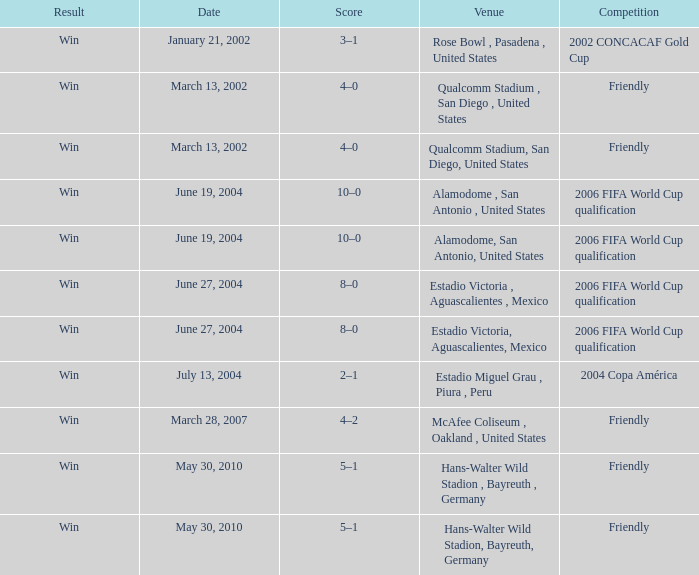Would you mind parsing the complete table? {'header': ['Result', 'Date', 'Score', 'Venue', 'Competition'], 'rows': [['Win', 'January 21, 2002', '3–1', 'Rose Bowl , Pasadena , United States', '2002 CONCACAF Gold Cup'], ['Win', 'March 13, 2002', '4–0', 'Qualcomm Stadium , San Diego , United States', 'Friendly'], ['Win', 'March 13, 2002', '4–0', 'Qualcomm Stadium, San Diego, United States', 'Friendly'], ['Win', 'June 19, 2004', '10–0', 'Alamodome , San Antonio , United States', '2006 FIFA World Cup qualification'], ['Win', 'June 19, 2004', '10–0', 'Alamodome, San Antonio, United States', '2006 FIFA World Cup qualification'], ['Win', 'June 27, 2004', '8–0', 'Estadio Victoria , Aguascalientes , Mexico', '2006 FIFA World Cup qualification'], ['Win', 'June 27, 2004', '8–0', 'Estadio Victoria, Aguascalientes, Mexico', '2006 FIFA World Cup qualification'], ['Win', 'July 13, 2004', '2–1', 'Estadio Miguel Grau , Piura , Peru', '2004 Copa América'], ['Win', 'March 28, 2007', '4–2', 'McAfee Coliseum , Oakland , United States', 'Friendly'], ['Win', 'May 30, 2010', '5–1', 'Hans-Walter Wild Stadion , Bayreuth , Germany', 'Friendly'], ['Win', 'May 30, 2010', '5–1', 'Hans-Walter Wild Stadion, Bayreuth, Germany', 'Friendly']]} What result has January 21, 2002 as the date? Win. 